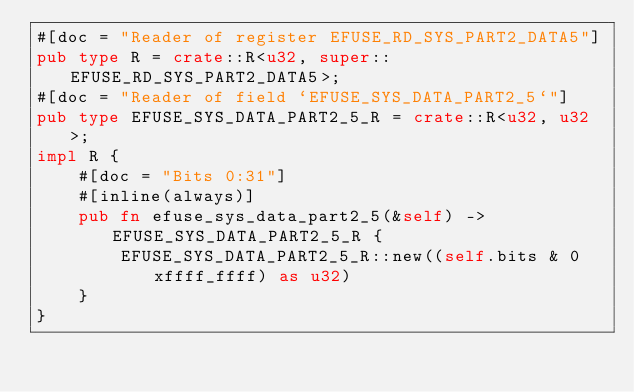Convert code to text. <code><loc_0><loc_0><loc_500><loc_500><_Rust_>#[doc = "Reader of register EFUSE_RD_SYS_PART2_DATA5"]
pub type R = crate::R<u32, super::EFUSE_RD_SYS_PART2_DATA5>;
#[doc = "Reader of field `EFUSE_SYS_DATA_PART2_5`"]
pub type EFUSE_SYS_DATA_PART2_5_R = crate::R<u32, u32>;
impl R {
    #[doc = "Bits 0:31"]
    #[inline(always)]
    pub fn efuse_sys_data_part2_5(&self) -> EFUSE_SYS_DATA_PART2_5_R {
        EFUSE_SYS_DATA_PART2_5_R::new((self.bits & 0xffff_ffff) as u32)
    }
}
</code> 